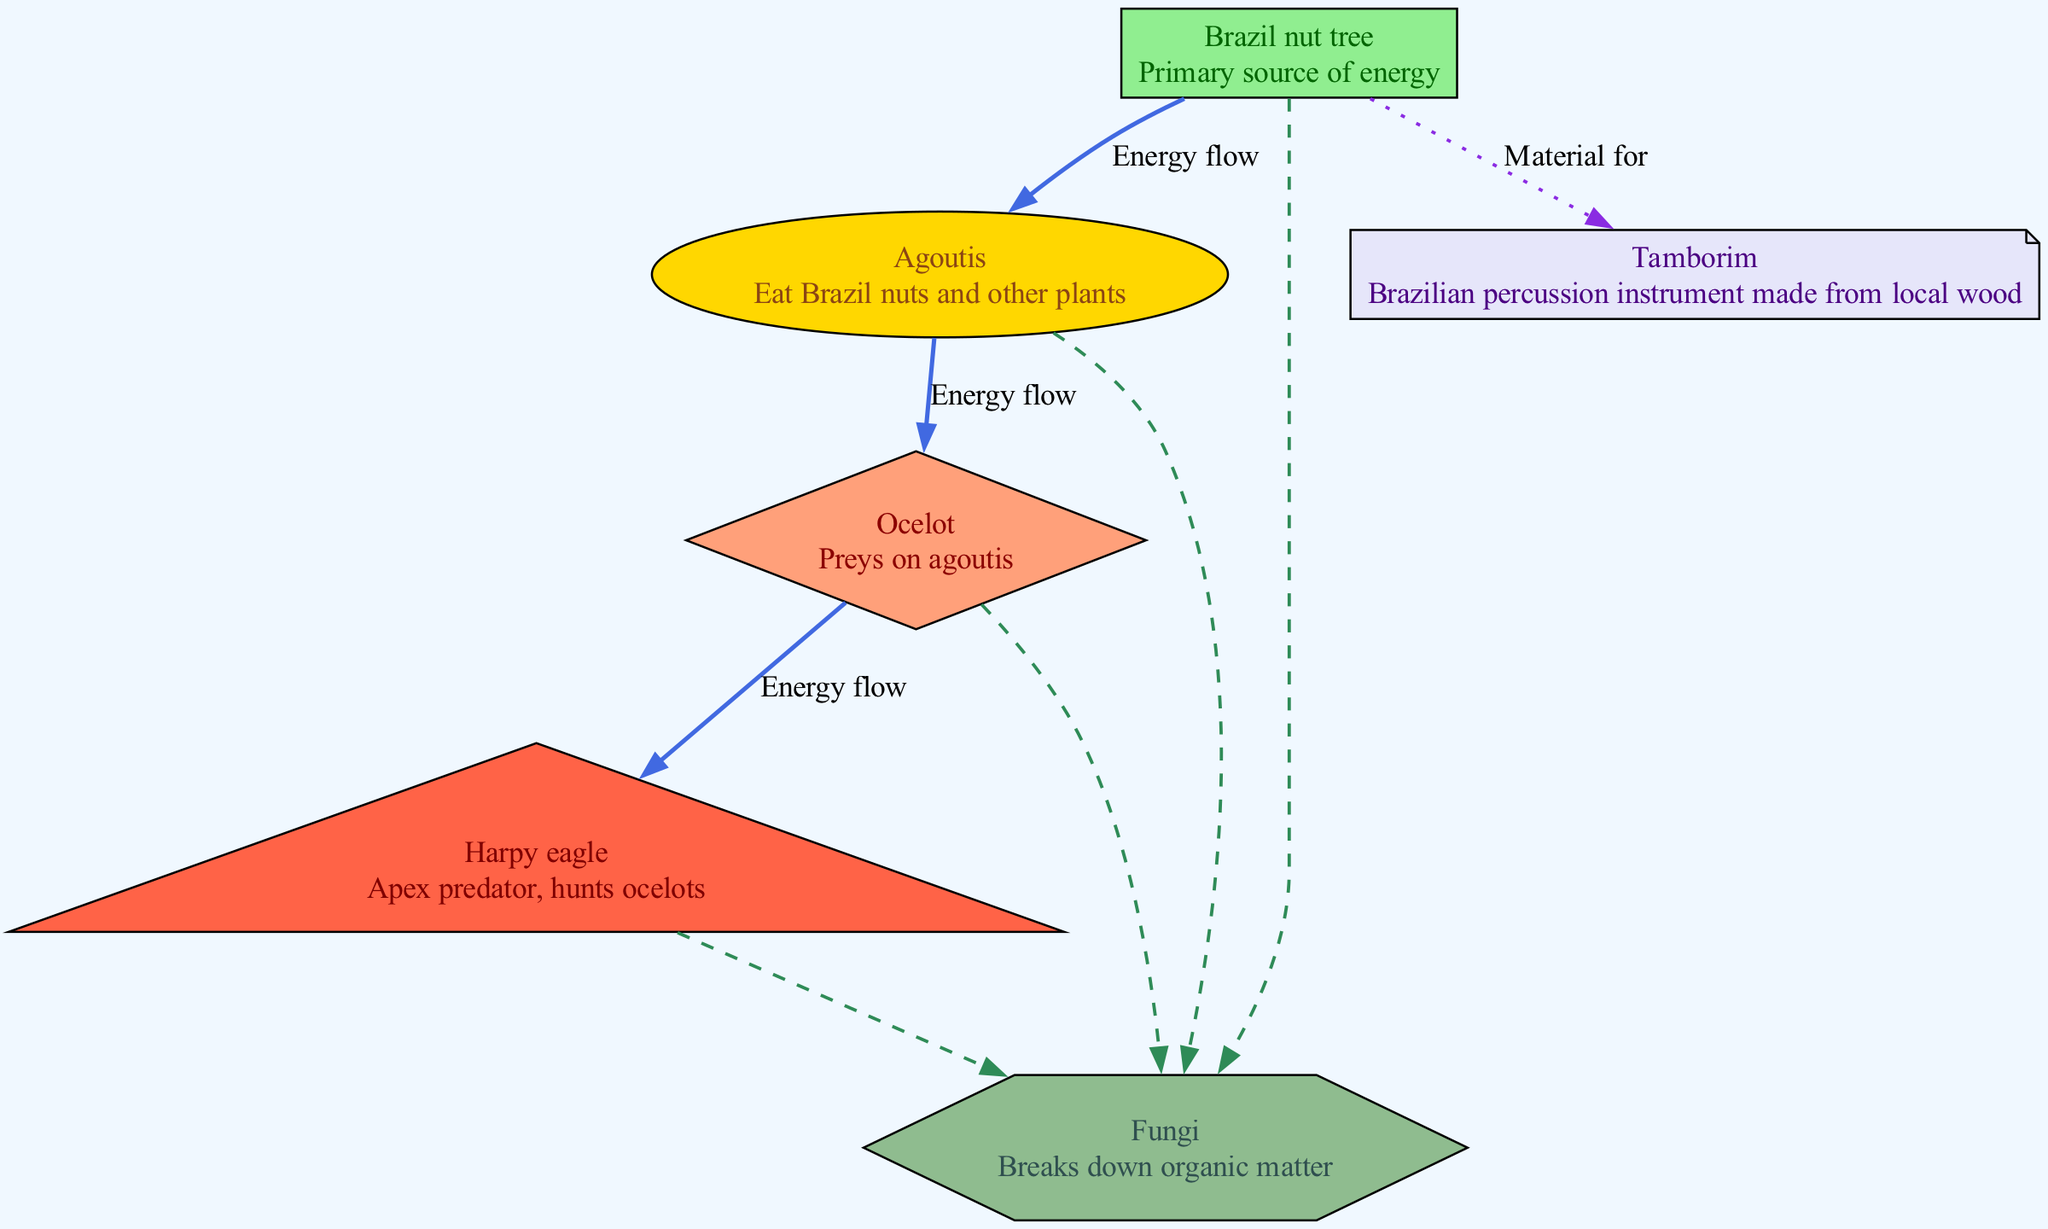What is the primary producer in the diagram? The diagram clearly labels the "Brazil nut tree" as the primary producer, which is a source of energy in the food chain.
Answer: Brazil nut tree Who preys on agoutis? Looking at the diagram, the "Ocelot" is indicated as the organism that preys on the "Agoutis," forming a connection in the food chain.
Answer: Ocelot How many consumers are represented in the food chain? By counting the nodes, we identify three consumers: "Agoutis," "Ocelot," and "Harpy eagle," therefore the total number of consumers is three.
Answer: 3 What type of flow is represented between the "Ocelot" and "Harpy eagle"? The edge connecting "Ocelot" and "Harpy eagle" is labeled "Energy flow," indicating the type of relationship that exists between these two nodes.
Answer: Energy flow What role do fungi play in this ecosystem? The diagram categorizes "Fungi" as decomposers, which signals that they are responsible for breaking down organic matter in the ecosystem, thus playing a significant ecological role.
Answer: Decomposer From which organism is tamborim made? The diagram shows a dotted line from the "Brazil nut tree" to the "Tamborim," indicating that tamborim is made from the material obtained from the Brazil nut tree.
Answer: Brazil nut tree Which organism is the apex predator? According to the diagram, the "Harpy eagle" is positioned at the top of the food chain, making it the apex predator in this ecosystem.
Answer: Harpy eagle What type of relationship exists between the "Brazil nut tree" and "Fungi"? The diagram illustrates a dashed line from "Brazil nut tree" to "Fungi," indicating a "breaks down" relationship where fungi decompose organic matter.
Answer: Breaks down How is energy transferred up the food chain? The diagram specifies that "Energy flow" is the mechanism that facilitates the transfer of energy from the producer to the consumers, making it a crucial process in the ecosystem's energy dynamics.
Answer: Energy flow 